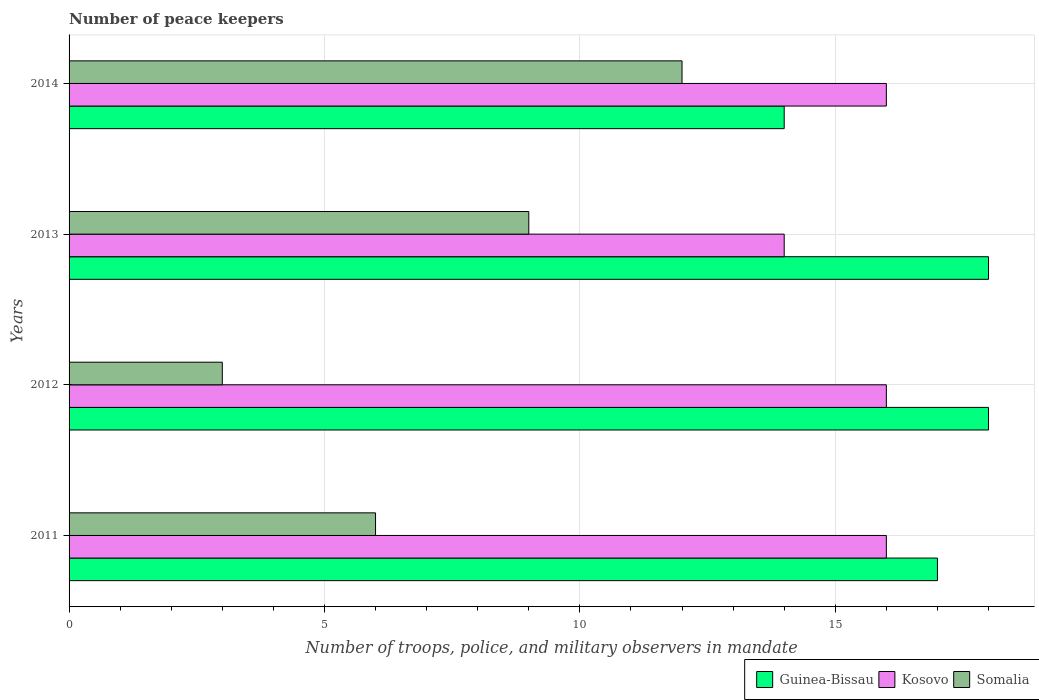How many groups of bars are there?
Offer a very short reply. 4. Are the number of bars per tick equal to the number of legend labels?
Offer a terse response. Yes. Are the number of bars on each tick of the Y-axis equal?
Your answer should be compact. Yes. What is the label of the 4th group of bars from the top?
Provide a short and direct response. 2011. In how many cases, is the number of bars for a given year not equal to the number of legend labels?
Provide a short and direct response. 0. What is the number of peace keepers in in Kosovo in 2013?
Provide a succinct answer. 14. In which year was the number of peace keepers in in Guinea-Bissau maximum?
Offer a terse response. 2012. What is the total number of peace keepers in in Somalia in the graph?
Ensure brevity in your answer.  30. What is the difference between the number of peace keepers in in Kosovo in 2013 and that in 2014?
Provide a short and direct response. -2. What is the difference between the number of peace keepers in in Somalia in 2011 and the number of peace keepers in in Kosovo in 2014?
Make the answer very short. -10. What is the average number of peace keepers in in Somalia per year?
Provide a succinct answer. 7.5. In the year 2013, what is the difference between the number of peace keepers in in Kosovo and number of peace keepers in in Somalia?
Your response must be concise. 5. Is the number of peace keepers in in Somalia in 2013 less than that in 2014?
Provide a short and direct response. Yes. What is the difference between the highest and the lowest number of peace keepers in in Kosovo?
Ensure brevity in your answer.  2. In how many years, is the number of peace keepers in in Kosovo greater than the average number of peace keepers in in Kosovo taken over all years?
Keep it short and to the point. 3. What does the 1st bar from the top in 2014 represents?
Make the answer very short. Somalia. What does the 1st bar from the bottom in 2011 represents?
Keep it short and to the point. Guinea-Bissau. Is it the case that in every year, the sum of the number of peace keepers in in Guinea-Bissau and number of peace keepers in in Kosovo is greater than the number of peace keepers in in Somalia?
Make the answer very short. Yes. How many bars are there?
Offer a terse response. 12. How many years are there in the graph?
Give a very brief answer. 4. What is the difference between two consecutive major ticks on the X-axis?
Provide a short and direct response. 5. Are the values on the major ticks of X-axis written in scientific E-notation?
Your answer should be compact. No. Does the graph contain any zero values?
Offer a terse response. No. How many legend labels are there?
Make the answer very short. 3. What is the title of the graph?
Provide a short and direct response. Number of peace keepers. Does "West Bank and Gaza" appear as one of the legend labels in the graph?
Offer a very short reply. No. What is the label or title of the X-axis?
Ensure brevity in your answer.  Number of troops, police, and military observers in mandate. What is the Number of troops, police, and military observers in mandate of Kosovo in 2011?
Ensure brevity in your answer.  16. What is the Number of troops, police, and military observers in mandate of Kosovo in 2012?
Offer a very short reply. 16. What is the Number of troops, police, and military observers in mandate in Guinea-Bissau in 2013?
Make the answer very short. 18. What is the Number of troops, police, and military observers in mandate in Kosovo in 2013?
Keep it short and to the point. 14. What is the Number of troops, police, and military observers in mandate in Guinea-Bissau in 2014?
Give a very brief answer. 14. What is the Number of troops, police, and military observers in mandate in Somalia in 2014?
Offer a terse response. 12. Across all years, what is the maximum Number of troops, police, and military observers in mandate in Somalia?
Your answer should be very brief. 12. Across all years, what is the minimum Number of troops, police, and military observers in mandate of Guinea-Bissau?
Offer a terse response. 14. Across all years, what is the minimum Number of troops, police, and military observers in mandate in Kosovo?
Provide a succinct answer. 14. Across all years, what is the minimum Number of troops, police, and military observers in mandate in Somalia?
Make the answer very short. 3. What is the total Number of troops, police, and military observers in mandate of Somalia in the graph?
Provide a short and direct response. 30. What is the difference between the Number of troops, police, and military observers in mandate in Guinea-Bissau in 2011 and that in 2012?
Your answer should be compact. -1. What is the difference between the Number of troops, police, and military observers in mandate in Kosovo in 2011 and that in 2012?
Provide a succinct answer. 0. What is the difference between the Number of troops, police, and military observers in mandate in Kosovo in 2011 and that in 2013?
Offer a very short reply. 2. What is the difference between the Number of troops, police, and military observers in mandate in Kosovo in 2011 and that in 2014?
Give a very brief answer. 0. What is the difference between the Number of troops, police, and military observers in mandate in Somalia in 2011 and that in 2014?
Offer a terse response. -6. What is the difference between the Number of troops, police, and military observers in mandate of Kosovo in 2012 and that in 2013?
Provide a succinct answer. 2. What is the difference between the Number of troops, police, and military observers in mandate of Somalia in 2012 and that in 2013?
Your answer should be compact. -6. What is the difference between the Number of troops, police, and military observers in mandate in Kosovo in 2012 and that in 2014?
Offer a terse response. 0. What is the difference between the Number of troops, police, and military observers in mandate in Somalia in 2012 and that in 2014?
Provide a succinct answer. -9. What is the difference between the Number of troops, police, and military observers in mandate of Kosovo in 2013 and that in 2014?
Provide a short and direct response. -2. What is the difference between the Number of troops, police, and military observers in mandate of Somalia in 2013 and that in 2014?
Your response must be concise. -3. What is the difference between the Number of troops, police, and military observers in mandate in Guinea-Bissau in 2011 and the Number of troops, police, and military observers in mandate in Kosovo in 2012?
Keep it short and to the point. 1. What is the difference between the Number of troops, police, and military observers in mandate in Kosovo in 2011 and the Number of troops, police, and military observers in mandate in Somalia in 2012?
Your answer should be compact. 13. What is the difference between the Number of troops, police, and military observers in mandate in Guinea-Bissau in 2011 and the Number of troops, police, and military observers in mandate in Kosovo in 2013?
Give a very brief answer. 3. What is the difference between the Number of troops, police, and military observers in mandate in Guinea-Bissau in 2011 and the Number of troops, police, and military observers in mandate in Kosovo in 2014?
Offer a very short reply. 1. What is the difference between the Number of troops, police, and military observers in mandate in Kosovo in 2011 and the Number of troops, police, and military observers in mandate in Somalia in 2014?
Provide a short and direct response. 4. What is the difference between the Number of troops, police, and military observers in mandate in Guinea-Bissau in 2012 and the Number of troops, police, and military observers in mandate in Kosovo in 2013?
Your answer should be very brief. 4. What is the difference between the Number of troops, police, and military observers in mandate of Kosovo in 2012 and the Number of troops, police, and military observers in mandate of Somalia in 2013?
Give a very brief answer. 7. What is the difference between the Number of troops, police, and military observers in mandate in Guinea-Bissau in 2012 and the Number of troops, police, and military observers in mandate in Kosovo in 2014?
Your answer should be very brief. 2. What is the difference between the Number of troops, police, and military observers in mandate in Kosovo in 2012 and the Number of troops, police, and military observers in mandate in Somalia in 2014?
Make the answer very short. 4. What is the difference between the Number of troops, police, and military observers in mandate of Guinea-Bissau in 2013 and the Number of troops, police, and military observers in mandate of Kosovo in 2014?
Ensure brevity in your answer.  2. What is the difference between the Number of troops, police, and military observers in mandate in Guinea-Bissau in 2013 and the Number of troops, police, and military observers in mandate in Somalia in 2014?
Give a very brief answer. 6. What is the average Number of troops, police, and military observers in mandate of Guinea-Bissau per year?
Make the answer very short. 16.75. In the year 2011, what is the difference between the Number of troops, police, and military observers in mandate of Guinea-Bissau and Number of troops, police, and military observers in mandate of Somalia?
Ensure brevity in your answer.  11. In the year 2012, what is the difference between the Number of troops, police, and military observers in mandate in Guinea-Bissau and Number of troops, police, and military observers in mandate in Somalia?
Your answer should be very brief. 15. In the year 2012, what is the difference between the Number of troops, police, and military observers in mandate in Kosovo and Number of troops, police, and military observers in mandate in Somalia?
Ensure brevity in your answer.  13. In the year 2013, what is the difference between the Number of troops, police, and military observers in mandate in Guinea-Bissau and Number of troops, police, and military observers in mandate in Kosovo?
Give a very brief answer. 4. In the year 2013, what is the difference between the Number of troops, police, and military observers in mandate of Guinea-Bissau and Number of troops, police, and military observers in mandate of Somalia?
Provide a short and direct response. 9. In the year 2014, what is the difference between the Number of troops, police, and military observers in mandate in Guinea-Bissau and Number of troops, police, and military observers in mandate in Somalia?
Your answer should be very brief. 2. In the year 2014, what is the difference between the Number of troops, police, and military observers in mandate in Kosovo and Number of troops, police, and military observers in mandate in Somalia?
Offer a very short reply. 4. What is the ratio of the Number of troops, police, and military observers in mandate of Kosovo in 2011 to that in 2012?
Provide a succinct answer. 1. What is the ratio of the Number of troops, police, and military observers in mandate of Somalia in 2011 to that in 2012?
Your answer should be compact. 2. What is the ratio of the Number of troops, police, and military observers in mandate in Kosovo in 2011 to that in 2013?
Provide a succinct answer. 1.14. What is the ratio of the Number of troops, police, and military observers in mandate in Guinea-Bissau in 2011 to that in 2014?
Your answer should be very brief. 1.21. What is the ratio of the Number of troops, police, and military observers in mandate in Kosovo in 2011 to that in 2014?
Ensure brevity in your answer.  1. What is the ratio of the Number of troops, police, and military observers in mandate in Kosovo in 2012 to that in 2013?
Make the answer very short. 1.14. What is the ratio of the Number of troops, police, and military observers in mandate in Somalia in 2012 to that in 2013?
Give a very brief answer. 0.33. What is the ratio of the Number of troops, police, and military observers in mandate of Guinea-Bissau in 2012 to that in 2014?
Give a very brief answer. 1.29. What is the ratio of the Number of troops, police, and military observers in mandate of Kosovo in 2012 to that in 2014?
Provide a short and direct response. 1. What is the ratio of the Number of troops, police, and military observers in mandate in Kosovo in 2013 to that in 2014?
Provide a succinct answer. 0.88. What is the difference between the highest and the second highest Number of troops, police, and military observers in mandate in Guinea-Bissau?
Keep it short and to the point. 0. What is the difference between the highest and the second highest Number of troops, police, and military observers in mandate in Kosovo?
Ensure brevity in your answer.  0. What is the difference between the highest and the second highest Number of troops, police, and military observers in mandate in Somalia?
Your answer should be compact. 3. What is the difference between the highest and the lowest Number of troops, police, and military observers in mandate in Kosovo?
Your response must be concise. 2. 